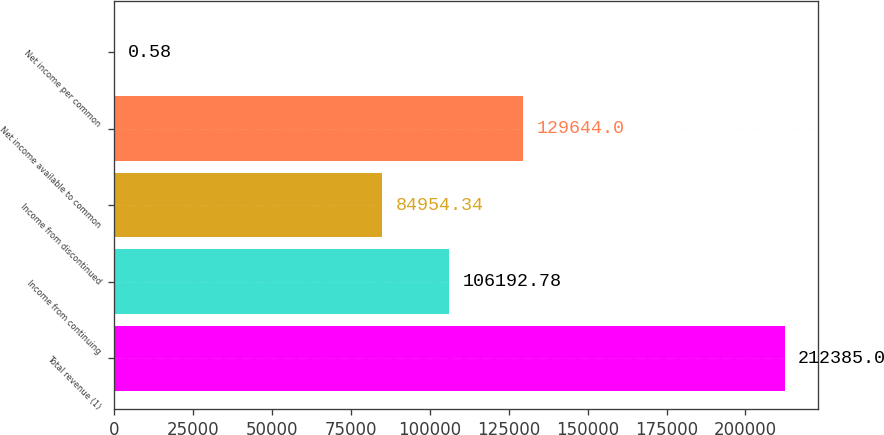<chart> <loc_0><loc_0><loc_500><loc_500><bar_chart><fcel>Total revenue (1)<fcel>Income from continuing<fcel>Income from discontinued<fcel>Net income available to common<fcel>Net income per common<nl><fcel>212385<fcel>106193<fcel>84954.3<fcel>129644<fcel>0.58<nl></chart> 